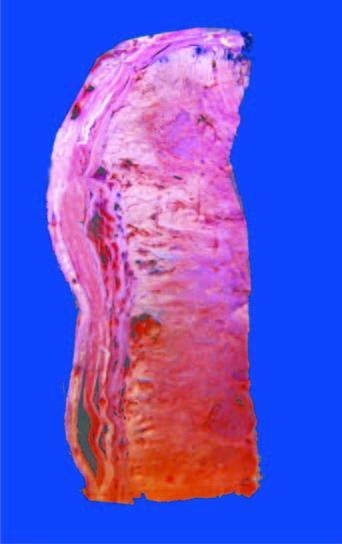s the corresponding area grey-white, cystic, soft and friable?
Answer the question using a single word or phrase. No 